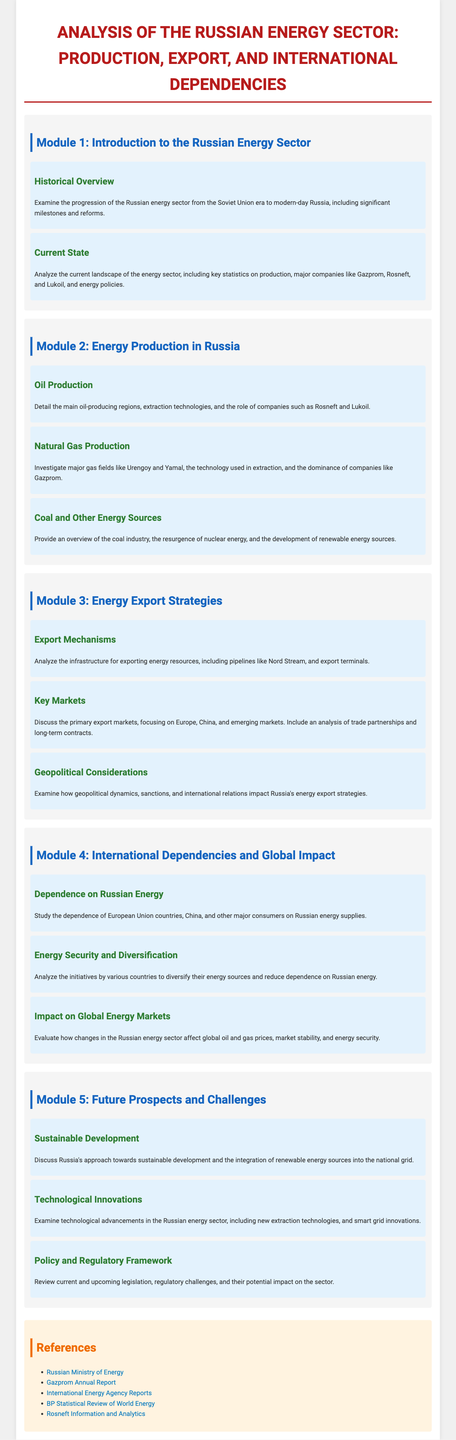What is the title of the syllabus? The title of the syllabus is the main heading and provides the subject matter covered in the syllabus.
Answer: Analysis of the Russian Energy Sector: Production, Export, and International Dependencies How many modules are there in the syllabus? The modules are clearly numbered, each covering different aspects of the energy sector.
Answer: 5 Which company is dominant in natural gas production? The document specifies key companies within each energy sector, identifying their roles.
Answer: Gazprom What are the two key markets discussed in the energy export strategies? These are mentioned in the module discussing export markets and partnerships.
Answer: Europe, China What is one technological innovation mentioned in the syllabus? The syllabus lists advancements that are important in the energy sector and discusses their significance.
Answer: Smart grid innovations What is the focus of Module 2? Module 2 outlines the specific topic being covered and provides an overview of Russia's energy production.
Answer: Energy Production in Russia Which energy field is highlighted in the natural gas production topic? A specific example must be drawn from the document addressing key gas fields.
Answer: Urengoy What is the concern of the geopolitical considerations topic? This topic addresses the influence of certain factors on Russia's ability to export energy efficiently.
Answer: International relations What initiative is discussed regarding energy security? The specific content related to how countries approach energy sourcing and security is addressed here.
Answer: Diversification 